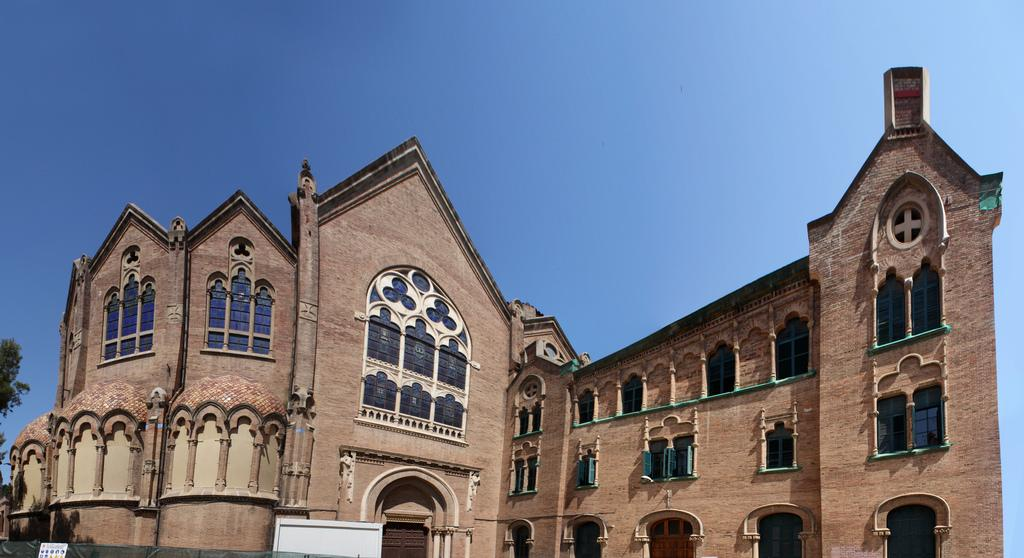What type of structure is visible in the image? There is a building in the image. Can you describe the walls of the building? The building has huge walls. What color is the sky in the image? The sky is blue in the image. What type of drum can be heard playing in the background of the image? There is no drum or sound present in the image; it is a still image of a building with huge walls and a blue sky. 